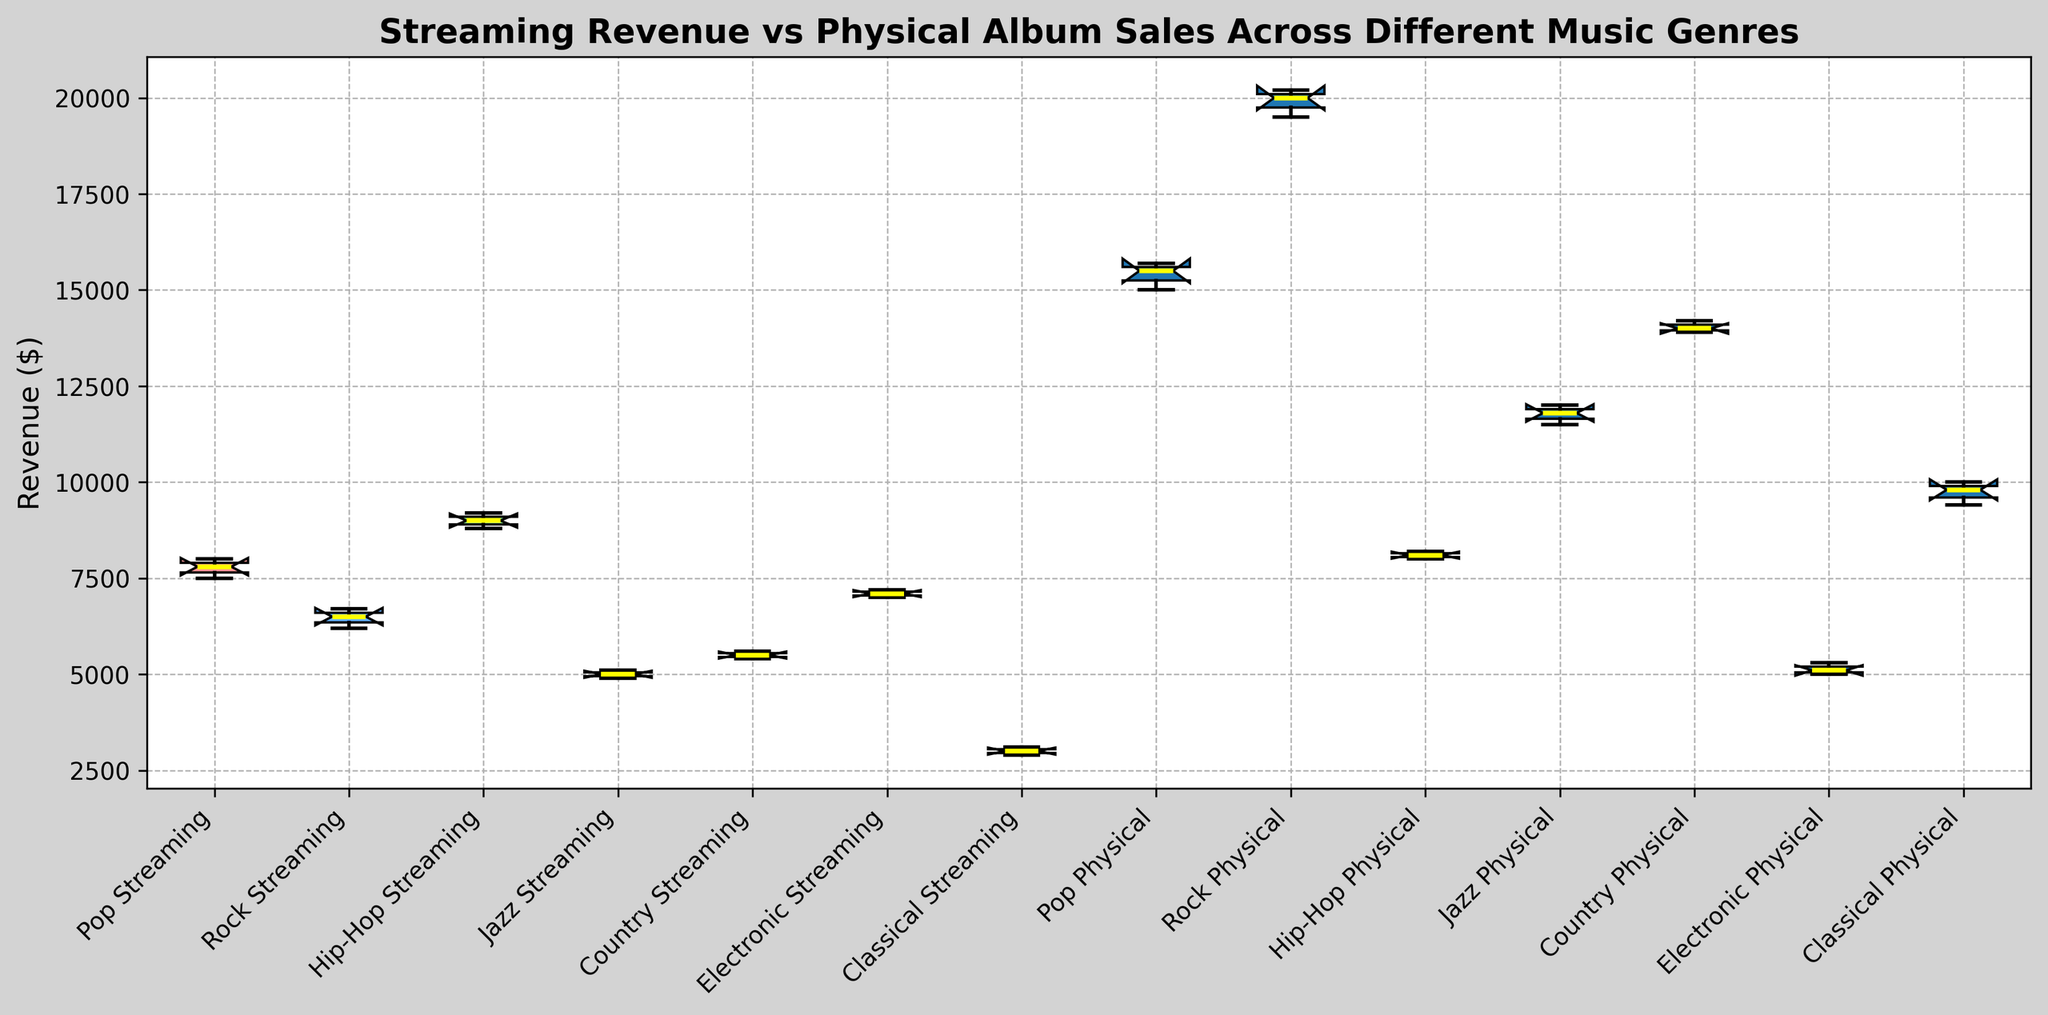Which genre has the highest median revenue from physical album sales? To find the highest median revenue for physical album sales, locate the median lines (yellow) for the "Physical" category in each genre's boxplot. Compare the heights.
Answer: Rock Which format shows higher revenue on average for Jazz, streaming or physical album sales? Look at the Jazz boxplots for both formats. The median line (yellow) for Physical appears much higher than the median line for Streaming.
Answer: Physical album sales What is the interquartile range (IQR) for Classical streaming revenue? To find the IQR, subtract the 25th percentile value (bottom of the box) from the 75th percentile value (top of the box) of the Classical Streaming boxplot.
Answer: 200 Is the variation in revenue greater for Pop or Country streaming? The greater the distance between the whiskers, the higher the variation. Compare the whisker lengths for Pop and Country in the Streaming category.
Answer: Pop Which genre has the smallest overall revenue range for physical album sales? The overall range is from the bottom whisker to the top whisker. Find the genre where the whiskers are closest for the Physical format.
Answer: Electronic What is the median revenue difference between streaming and physical sales for Electronic music? Find the median lines (yellow) for both Streaming and Physical formats within the Electronic genre and subtract them.
Answer: 2000 Are there any genres where the lowest revenue in physical sales is still higher than the highest streaming revenue? Identify if the bottom whisker of any Physical boxplot is higher than the top whisker of any Streaming boxplot.
Answer: Yes, Rock Which format has a more consistent revenue for Classical, according to the spread of the data? Consistency can be seen by a smaller spread between the whiskers. Compare the whisker lengths for Classical in both formats.
Answer: Streaming Does Hip-Hop show a significant difference between streaming and physical revenues? Compare the medians and ranges (whiskers and box) for Hip-Hop in both formats. If there's a large gap, it signifies a significant difference.
Answer: Yes What is the median streaming revenue for Pop music? Locate the yellow median line in the Pop Streaming boxplot.
Answer: 7800 